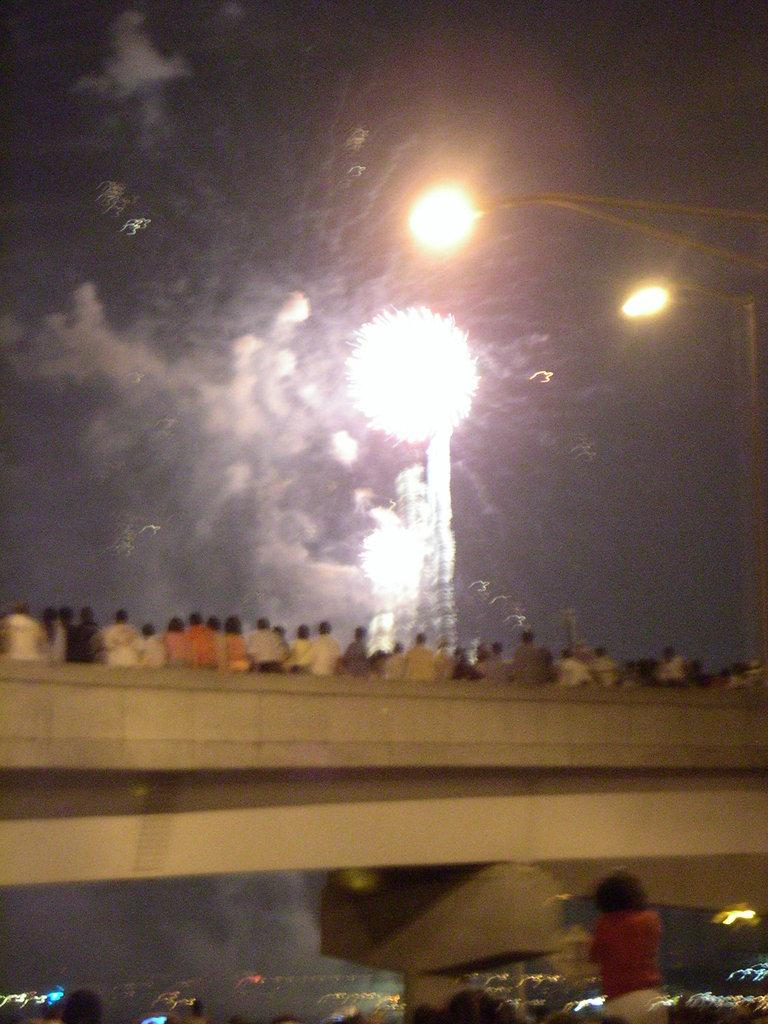What are the people in the image doing? There are persons standing on the bridge in the image. What can be seen in the sky in the image? There are fireworks in the sky in the image. What type of structures are visible along the bridge? Street poles are visible in the image. What provides illumination along the bridge? Street lights are present in the image. Where is the nest located in the image? There is no nest present in the image. What part of the elbow can be seen in the image? There are no elbows visible in the image. 